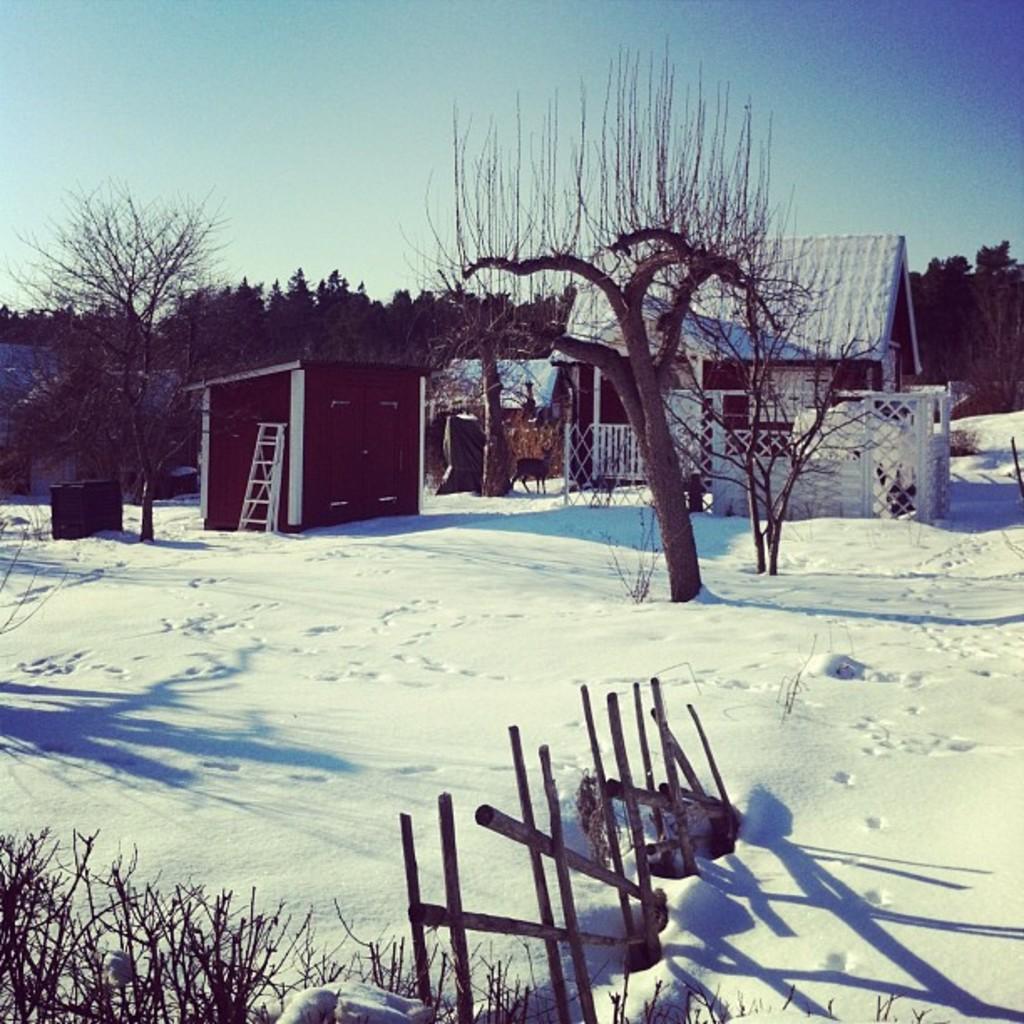Can you describe this image briefly? In this picture I can see there is some snow on the floor and there are few buildings and there are few trees and the sky is clear. 